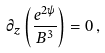Convert formula to latex. <formula><loc_0><loc_0><loc_500><loc_500>\partial _ { z } \left ( \frac { e ^ { 2 \psi } } { B ^ { 3 } } \right ) = 0 \, ,</formula> 